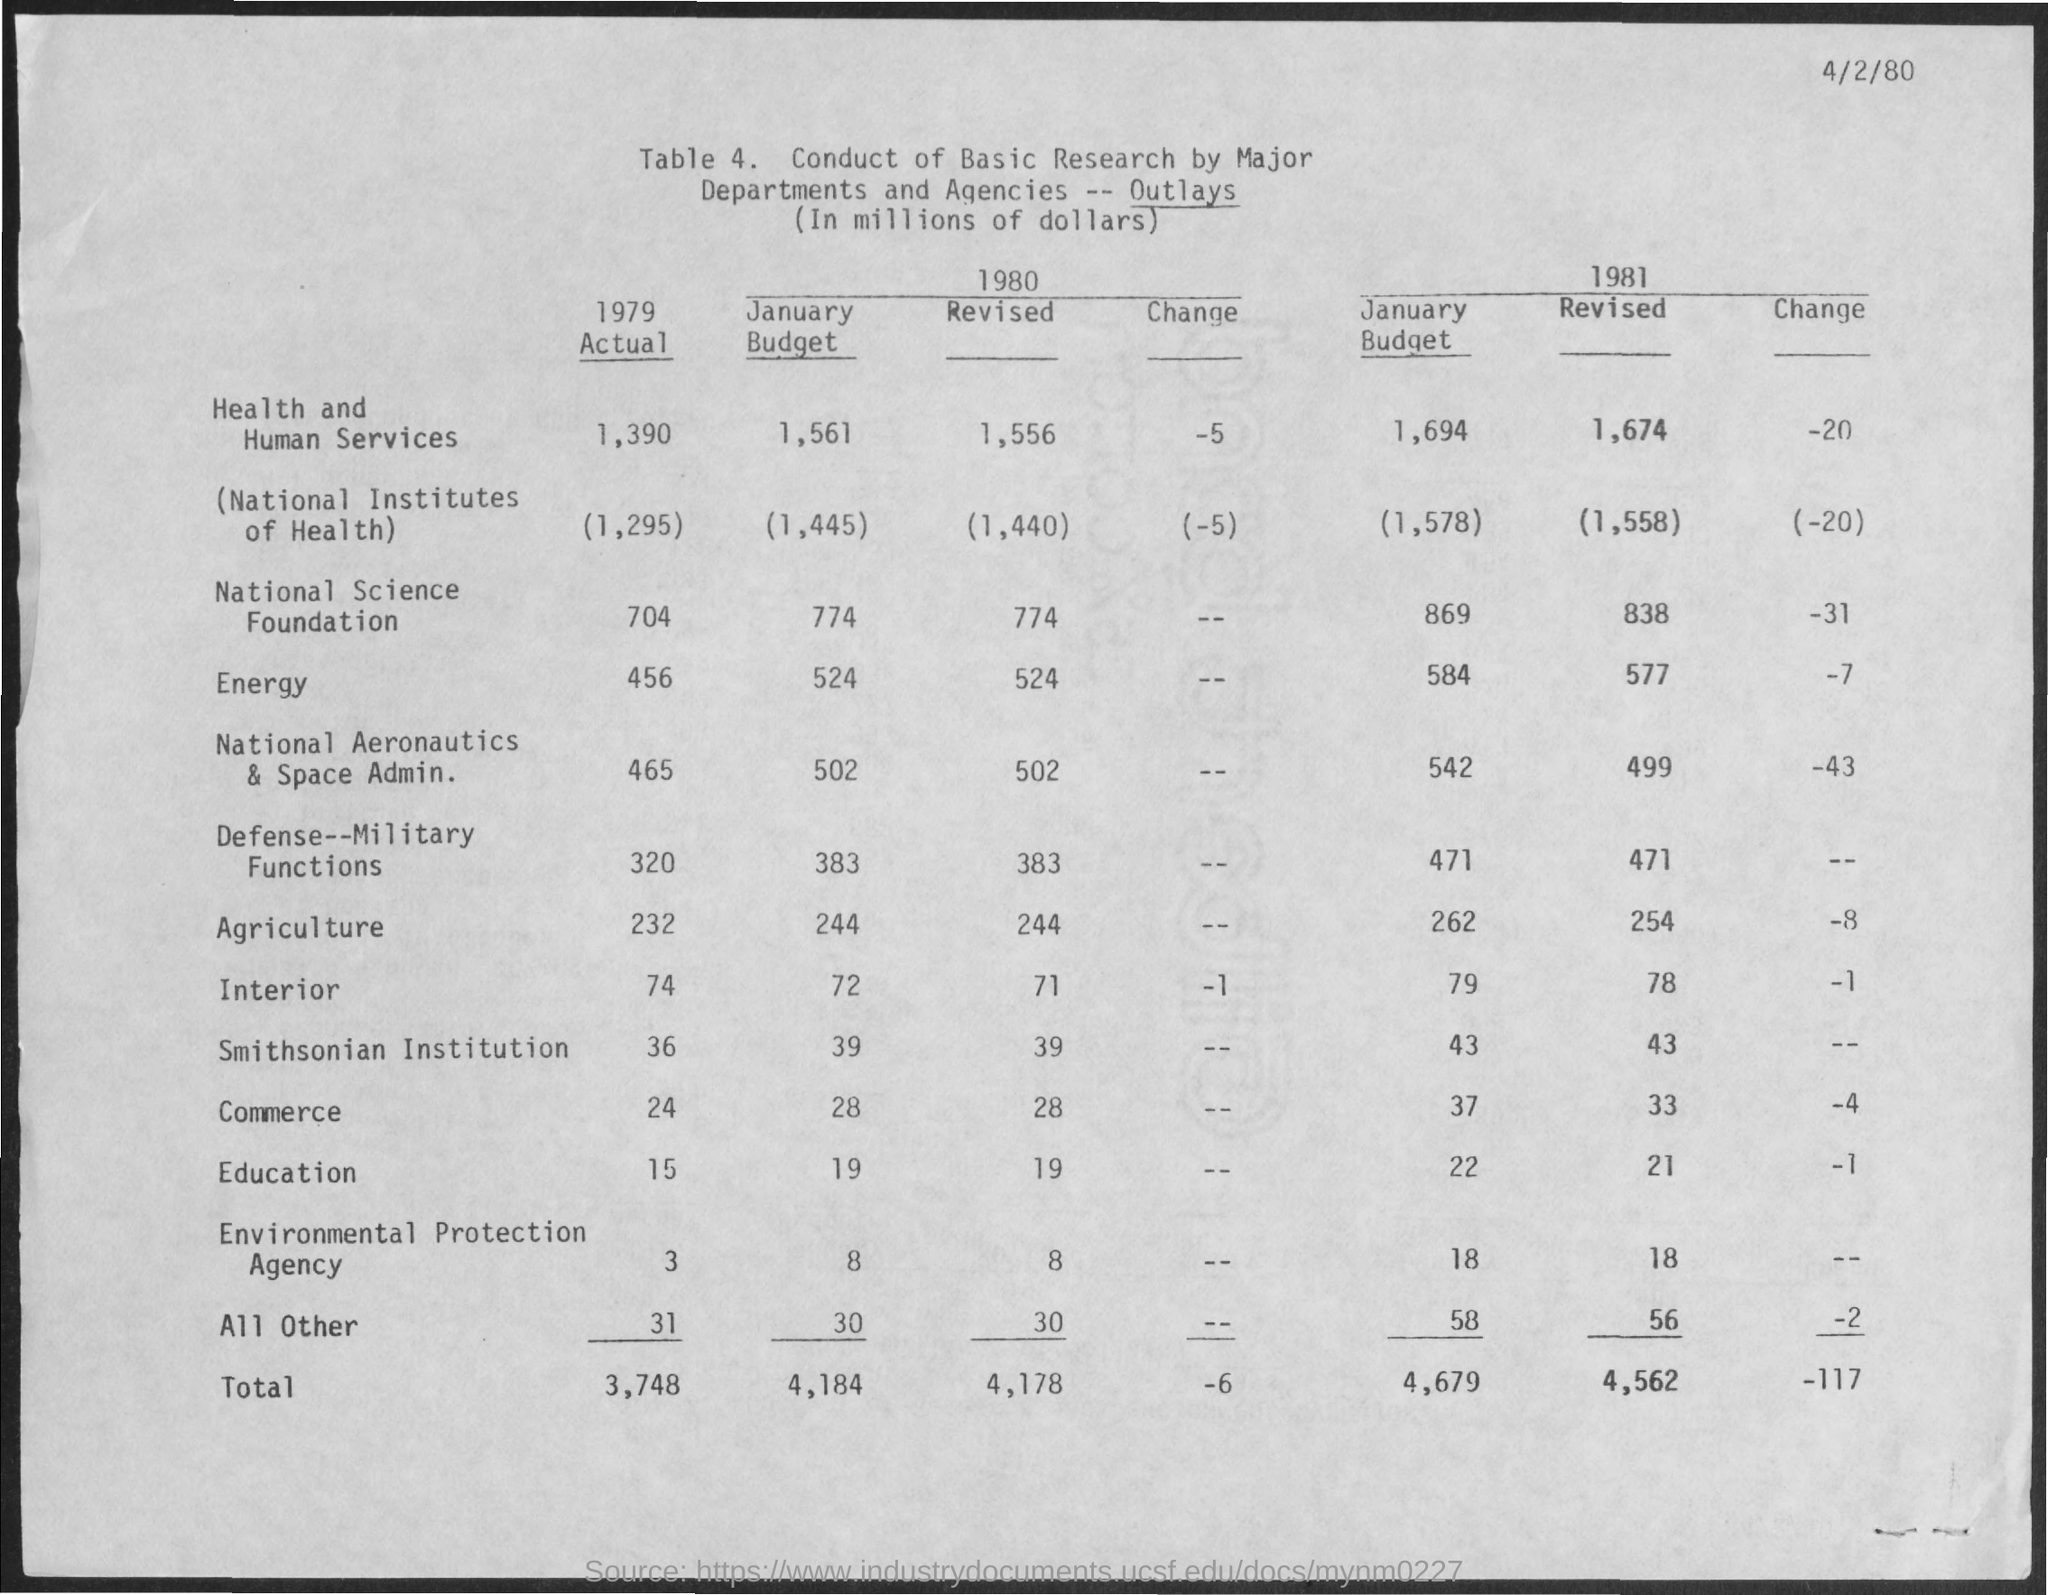Give some essential details in this illustration. The budget for interior in January 1981 was $79. The date mentioned at the top of the page is April 2nd, 1980. The January budget for agriculture in 1980 was $244 million. In the year 1980, the total budget for the month of January was 4,184. The January budget for agriculture in 1981 was 262. 